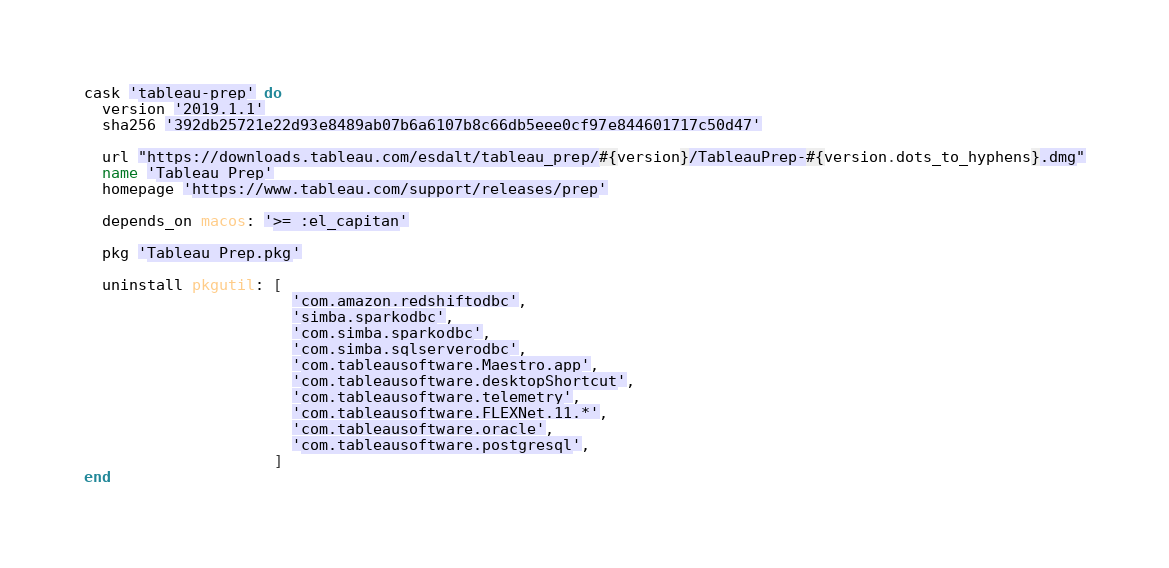Convert code to text. <code><loc_0><loc_0><loc_500><loc_500><_Ruby_>cask 'tableau-prep' do
  version '2019.1.1'
  sha256 '392db25721e22d93e8489ab07b6a6107b8c66db5eee0cf97e844601717c50d47'

  url "https://downloads.tableau.com/esdalt/tableau_prep/#{version}/TableauPrep-#{version.dots_to_hyphens}.dmg"
  name 'Tableau Prep'
  homepage 'https://www.tableau.com/support/releases/prep'

  depends_on macos: '>= :el_capitan'

  pkg 'Tableau Prep.pkg'

  uninstall pkgutil: [
                       'com.amazon.redshiftodbc',
                       'simba.sparkodbc',
                       'com.simba.sparkodbc',
                       'com.simba.sqlserverodbc',
                       'com.tableausoftware.Maestro.app',
                       'com.tableausoftware.desktopShortcut',
                       'com.tableausoftware.telemetry',
                       'com.tableausoftware.FLEXNet.11.*',
                       'com.tableausoftware.oracle',
                       'com.tableausoftware.postgresql',
                     ]
end
</code> 